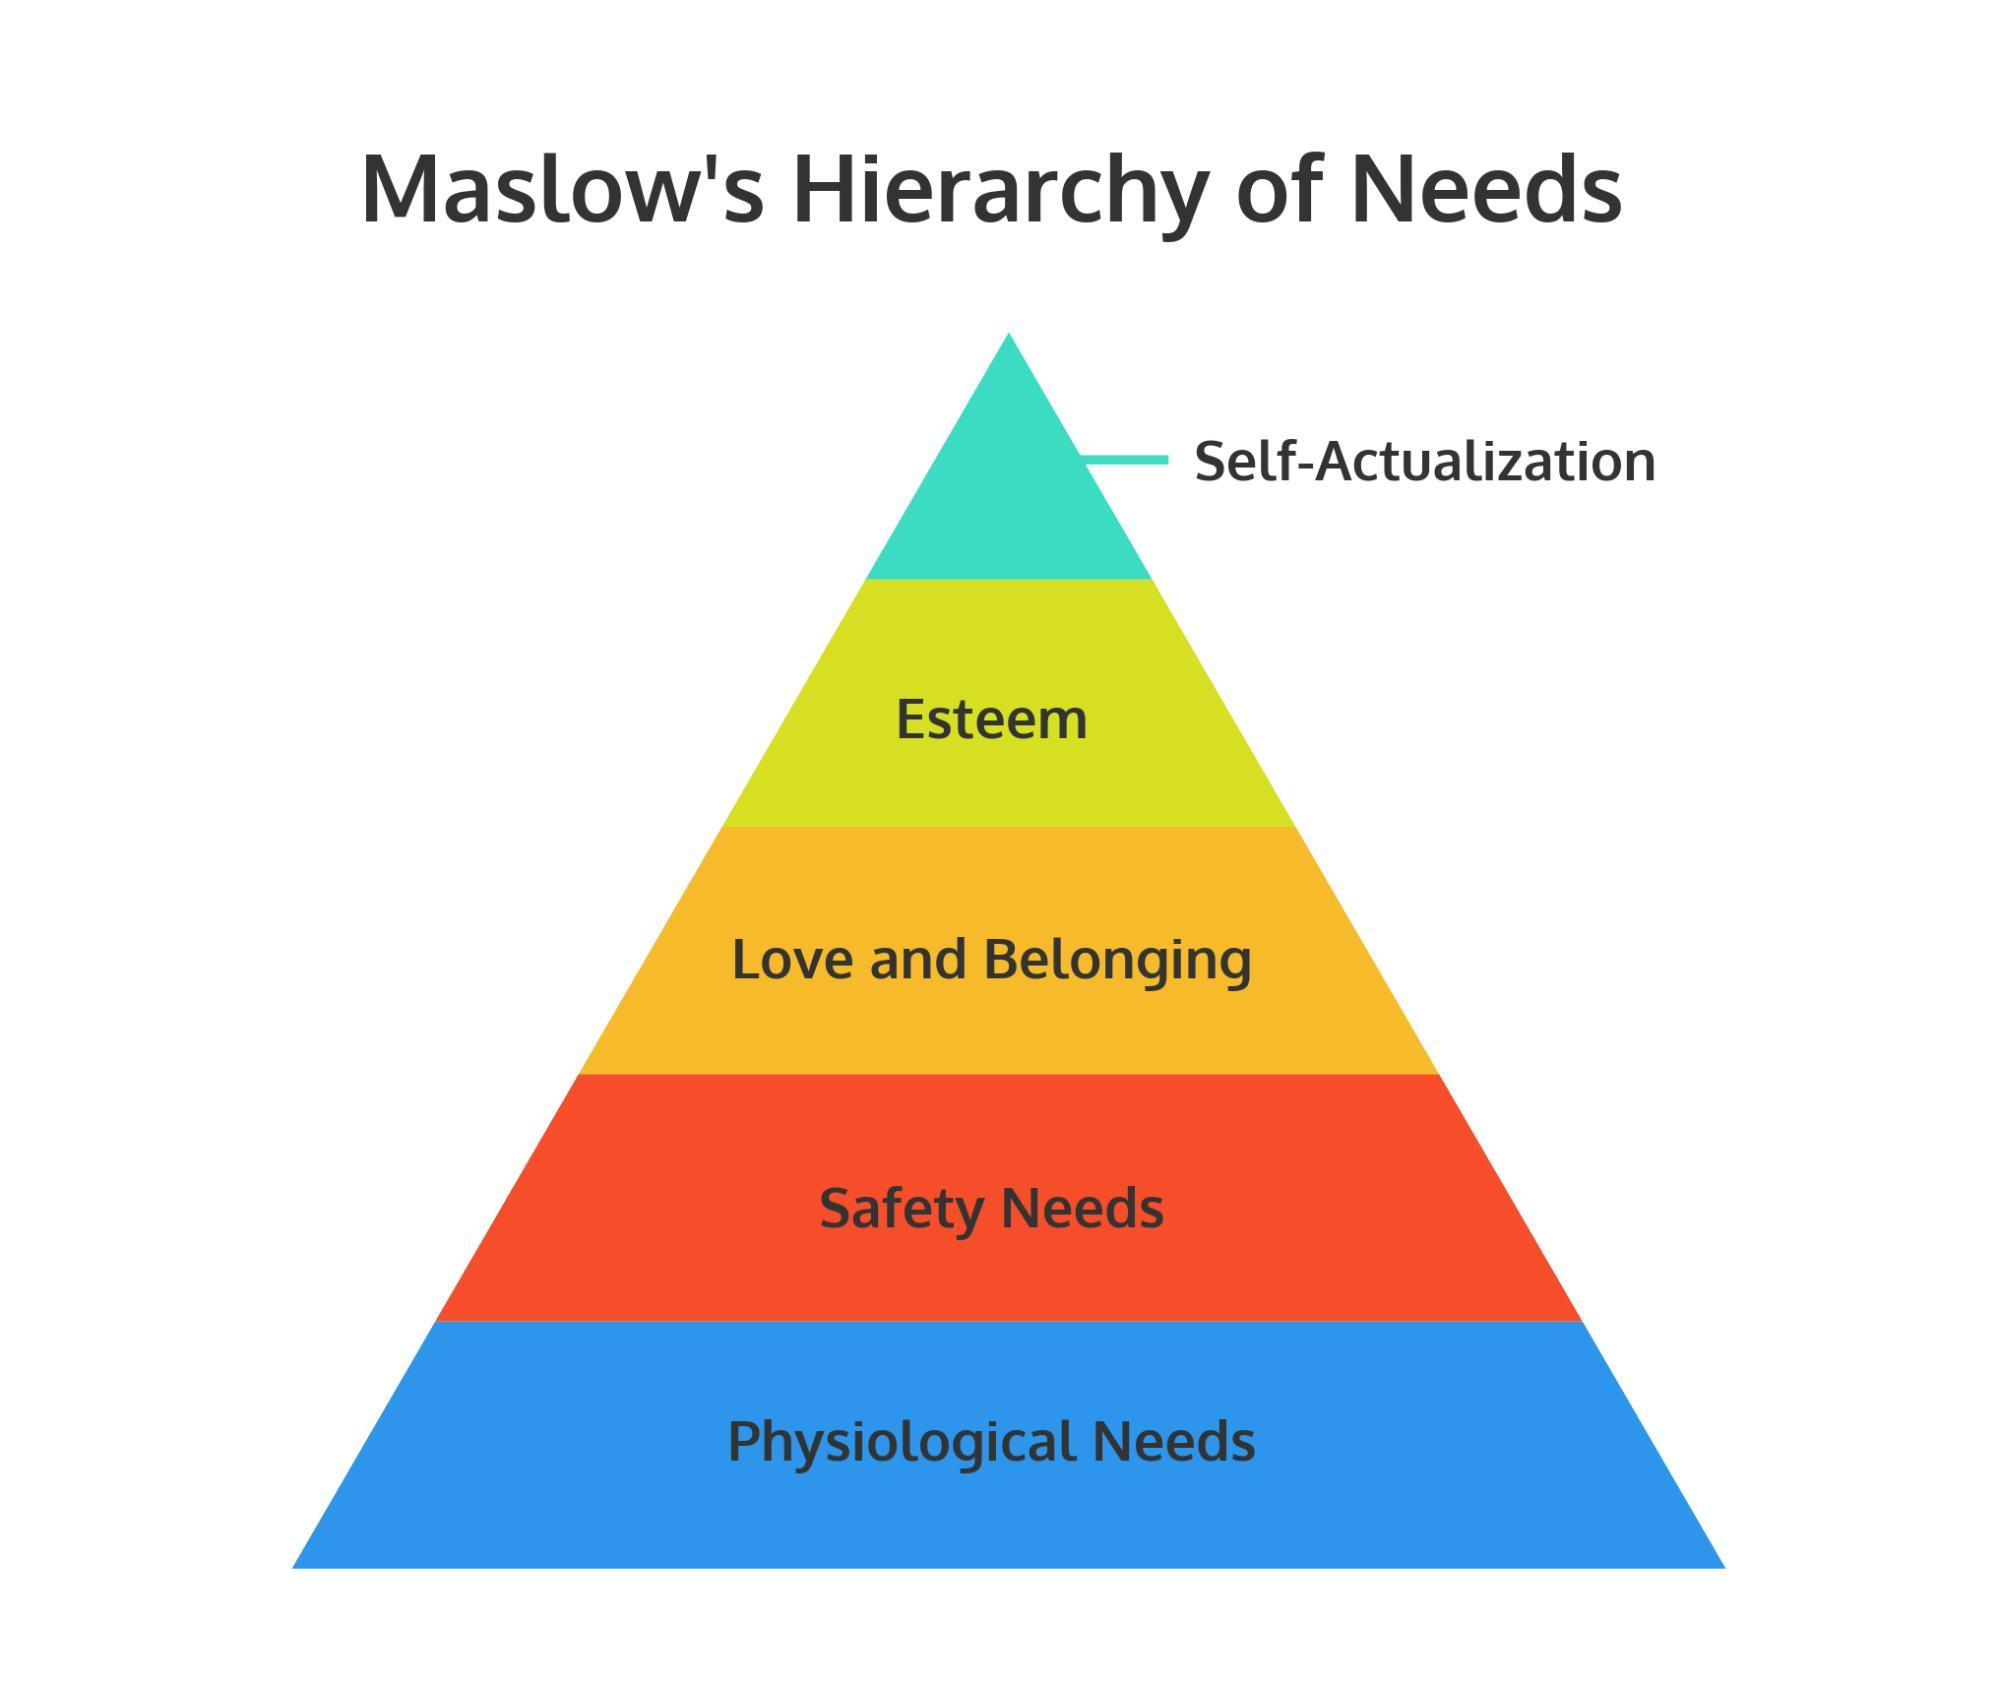In which shape, the Maslow's hierarchy of needs were depicted - square, triangle, cube or circle?
Answer the question with a short phrase. triangle What is the color of the block representing 'safety needs'- white, blue, green or red? red 